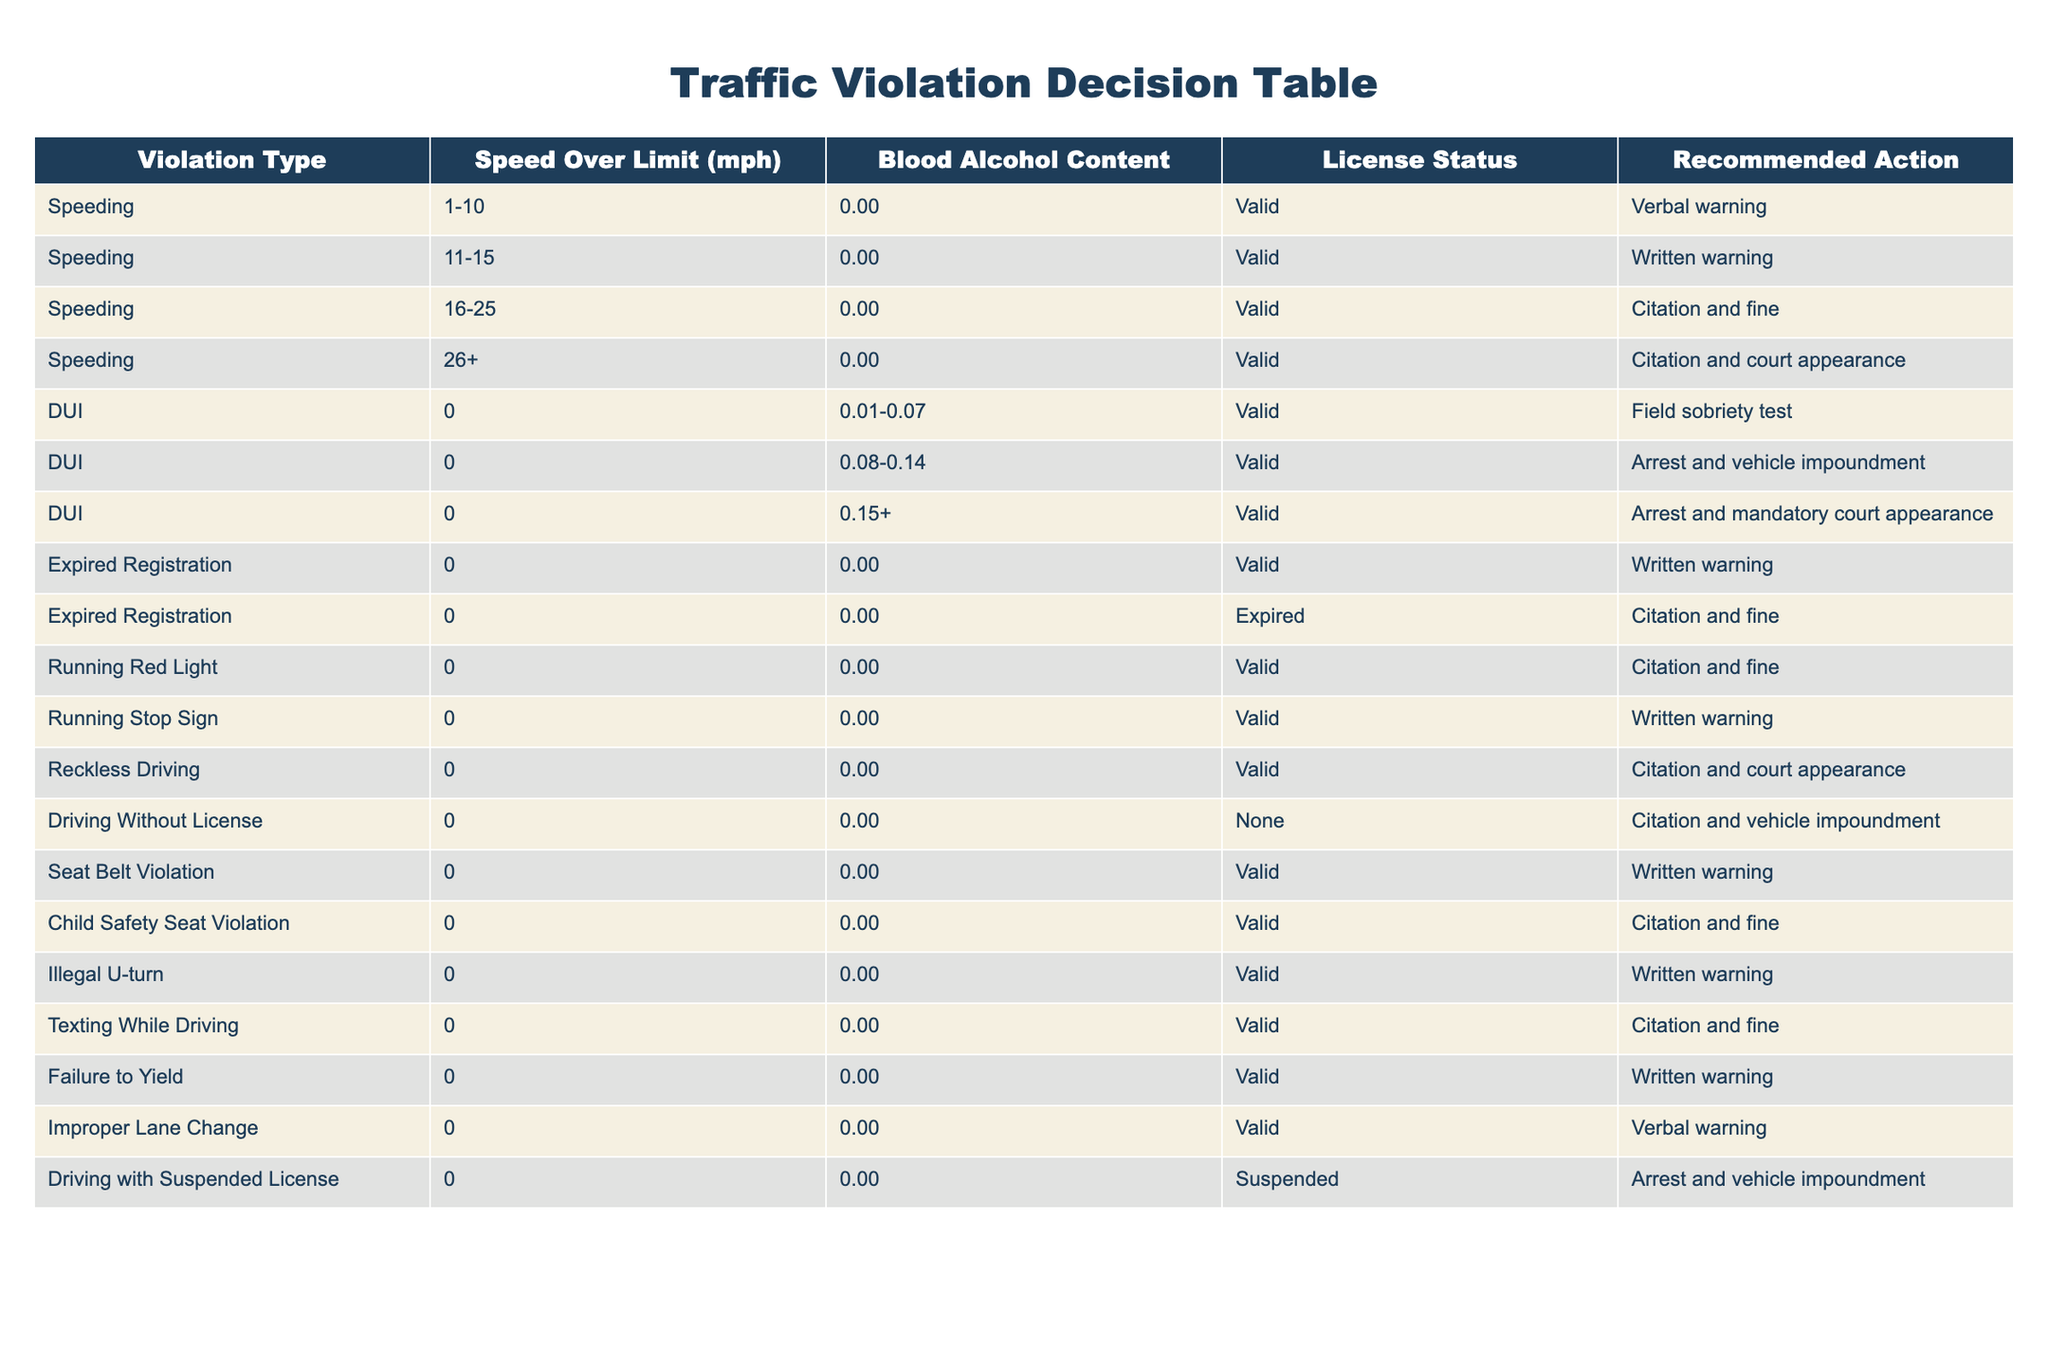What is the recommended action for speeding by 1-10 mph? According to the table, the recommended action for speeding by 1-10 mph with a valid license is a verbal warning.
Answer: Verbal warning How many different recommended actions are there for DUI violations? The table shows three types of DUI violations, each with a different recommended action: field sobriety test, arrest and vehicle impoundment, and arrest with a mandatory court appearance. Thus, there are three recommended actions for DUI violations.
Answer: Three Is a written warning given for running a stop sign? Yes, the table indicates that the recommended action for running a stop sign with a valid license is a written warning.
Answer: Yes What is the recommended action for driving without a license? The table specifies that the recommended action for driving without a license is citation and vehicle impoundment.
Answer: Citation and vehicle impoundment For what violation type is a citation and court appearance recommended? The table lists two types of violations with the recommended action of citation and court appearance: reckless driving and speeding over 26 mph.
Answer: Reckless driving and speeding over 26 mph What is the total number of violations listed in the table? The table contains 13 rows of violations, each representing a different type of traffic violation. Therefore, the total number of violations listed is 13.
Answer: 13 If a driver is caught speeding over 26 mph and has a blood alcohol content of 0.00, what is the recommended action? The table states that for speeding over 26 mph with a valid license (and 0.00 BAC), the recommended action is citation and court appearance.
Answer: Citation and court appearance Are there any violations that result in a verbal warning? Yes, the table indicates that speeding by 1-10 mph and improper lane change result in a verbal warning as the recommended action.
Answer: Yes What is the action taken for a driver with a suspended license? The table clearly states that for driving with a suspended license, the recommended action is arrest and vehicle impoundment.
Answer: Arrest and vehicle impoundment 